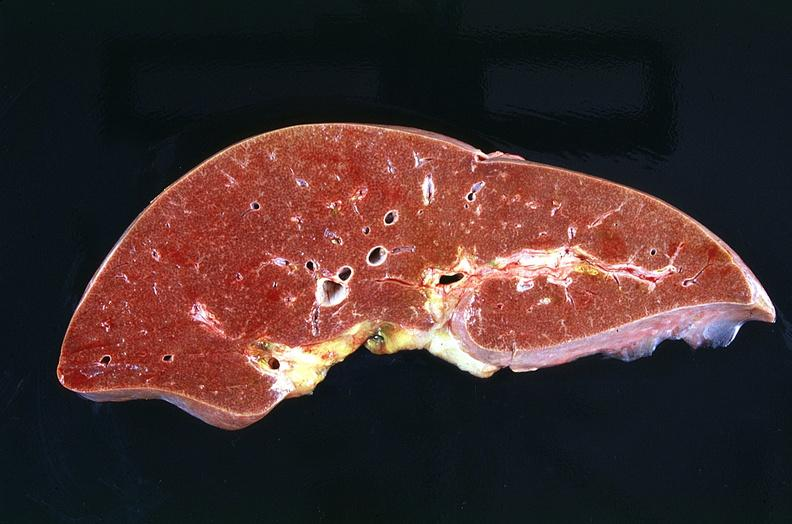what does this image show?
Answer the question using a single word or phrase. Liver 